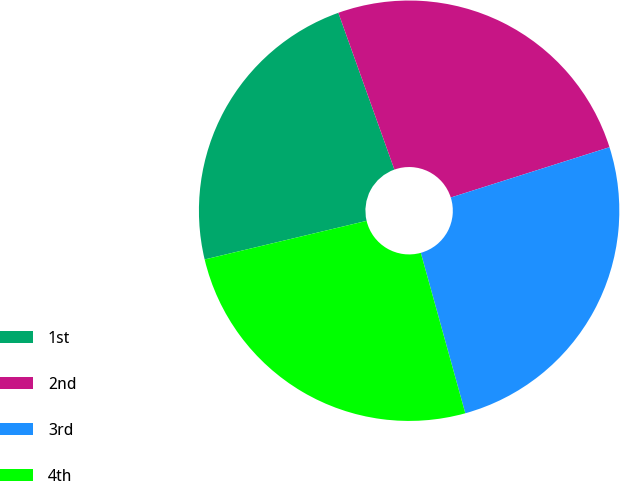Convert chart to OTSL. <chart><loc_0><loc_0><loc_500><loc_500><pie_chart><fcel>1st<fcel>2nd<fcel>3rd<fcel>4th<nl><fcel>23.26%<fcel>25.58%<fcel>25.58%<fcel>25.58%<nl></chart> 